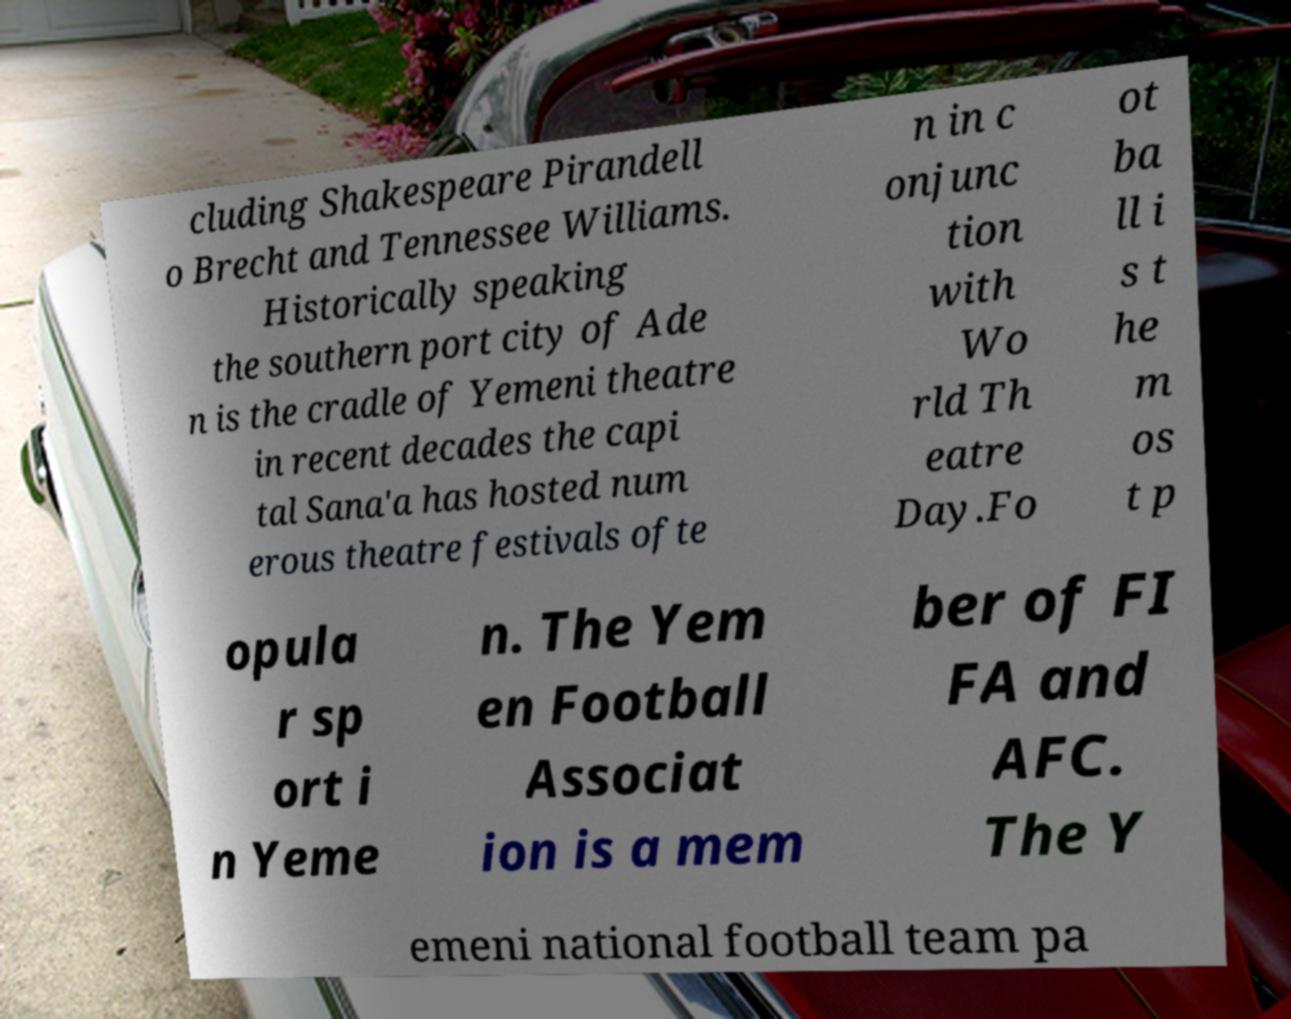Please identify and transcribe the text found in this image. cluding Shakespeare Pirandell o Brecht and Tennessee Williams. Historically speaking the southern port city of Ade n is the cradle of Yemeni theatre in recent decades the capi tal Sana'a has hosted num erous theatre festivals ofte n in c onjunc tion with Wo rld Th eatre Day.Fo ot ba ll i s t he m os t p opula r sp ort i n Yeme n. The Yem en Football Associat ion is a mem ber of FI FA and AFC. The Y emeni national football team pa 